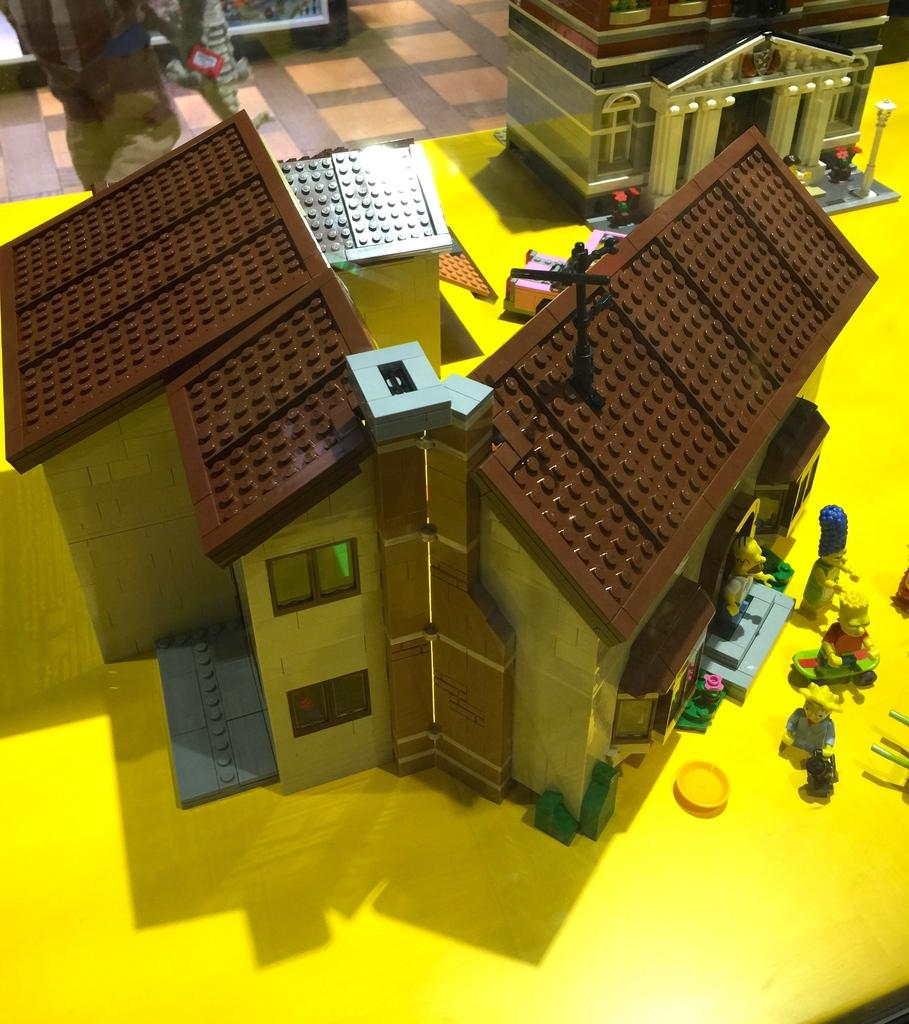What type of structure can be seen in the image? There is a building in the image. What else can be seen in the image besides the building? There are houses, people, a vehicle, flower pots, a light pole, objects, and a path in the image. What type of shoes are the frogs wearing while sitting on the linen in the image? There are no frogs or linen present in the image, and therefore no shoes can be observed. 